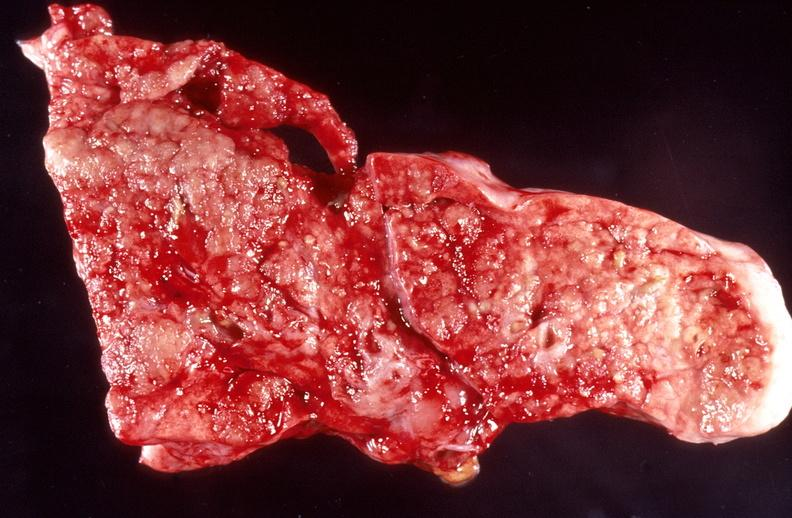s focal hemorrhagic infarction well shown present?
Answer the question using a single word or phrase. No 